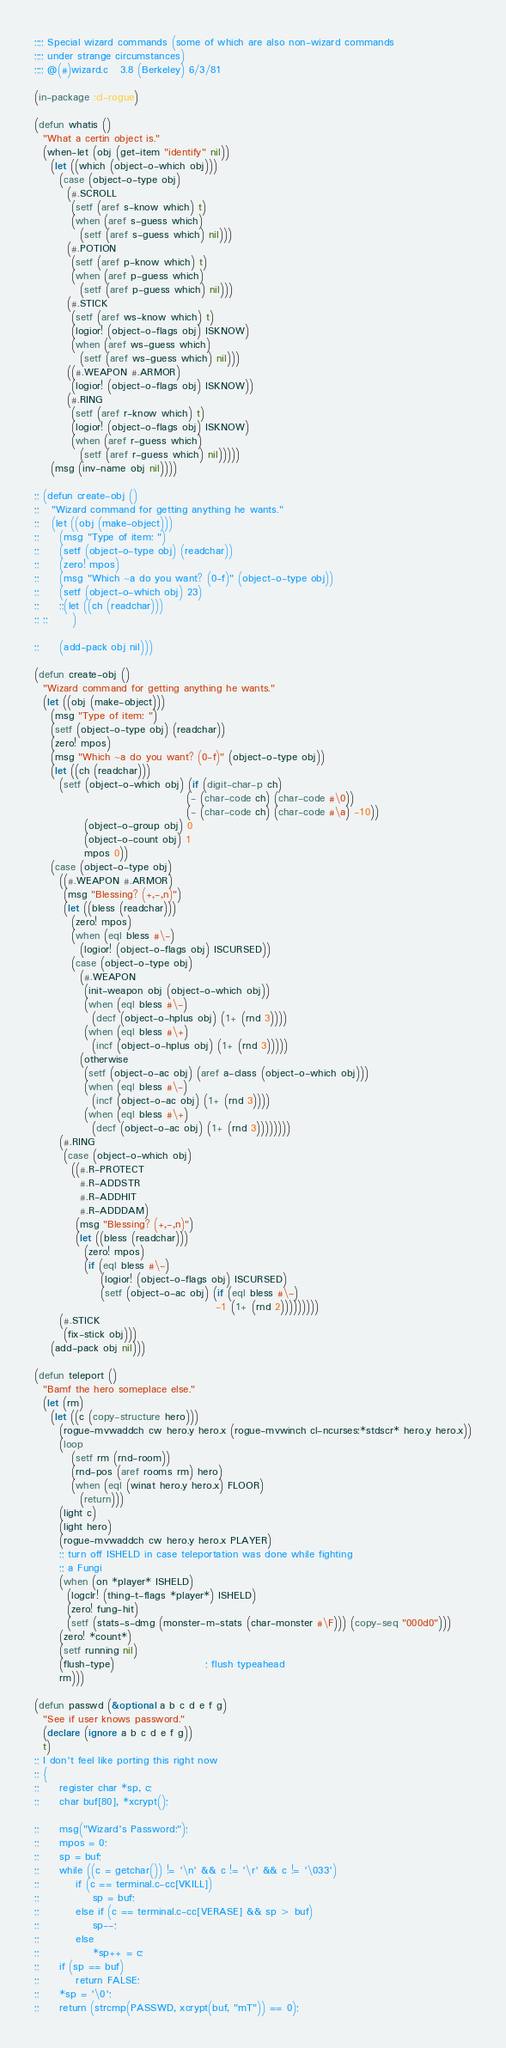<code> <loc_0><loc_0><loc_500><loc_500><_Lisp_>;;;; Special wizard commands (some of which are also non-wizard commands
;;;; under strange circumstances)
;;;; @(#)wizard.c	3.8 (Berkeley) 6/3/81

(in-package :cl-rogue)

(defun whatis ()
  "What a certin object is."
  (when-let (obj (get-item "identify" nil))
    (let ((which (object-o-which obj)))
      (case (object-o-type obj)
        (#.SCROLL
         (setf (aref s-know which) t)
         (when (aref s-guess which)
           (setf (aref s-guess which) nil)))
        (#.POTION
         (setf (aref p-know which) t)
         (when (aref p-guess which)
           (setf (aref p-guess which) nil)))
        (#.STICK
         (setf (aref ws-know which) t)
         (logior! (object-o-flags obj) ISKNOW)
         (when (aref ws-guess which)
           (setf (aref ws-guess which) nil)))
        ((#.WEAPON #.ARMOR)
         (logior! (object-o-flags obj) ISKNOW))
        (#.RING
         (setf (aref r-know which) t)
         (logior! (object-o-flags obj) ISKNOW)
         (when (aref r-guess which)
           (setf (aref r-guess which) nil)))))
    (msg (inv-name obj nil))))

;; (defun create-obj ()
;;   "Wizard command for getting anything he wants."
;;   (let ((obj (make-object)))
;;     (msg "Type of item: ")
;;     (setf (object-o-type obj) (readchar))
;;     (zero! mpos)
;;     (msg "Which ~a do you want? (0-f)" (object-o-type obj))
;;     (setf (object-o-which obj) 23)
;;     ;;(let ((ch (readchar)))
;; ;;      )
    
;;     (add-pack obj nil)))

(defun create-obj ()
  "Wizard command for getting anything he wants."
  (let ((obj (make-object)))
    (msg "Type of item: ")
    (setf (object-o-type obj) (readchar))
    (zero! mpos)
    (msg "Which ~a do you want? (0-f)" (object-o-type obj))
    (let ((ch (readchar)))
      (setf (object-o-which obj) (if (digit-char-p ch)
                                     (- (char-code ch) (char-code #\0))
                                     (- (char-code ch) (char-code #\a) -10))
            (object-o-group obj) 0
            (object-o-count obj) 1
            mpos 0))
    (case (object-o-type obj)
      ((#.WEAPON #.ARMOR)
       (msg "Blessing? (+,-,n)")
       (let ((bless (readchar)))
         (zero! mpos)
         (when (eql bless #\-)
           (logior! (object-o-flags obj) ISCURSED))
         (case (object-o-type obj)
           (#.WEAPON
            (init-weapon obj (object-o-which obj))
            (when (eql bless #\-)
              (decf (object-o-hplus obj) (1+ (rnd 3))))
            (when (eql bless #\+)
              (incf (object-o-hplus obj) (1+ (rnd 3)))))
           (otherwise
            (setf (object-o-ac obj) (aref a-class (object-o-which obj)))
            (when (eql bless #\-)
              (incf (object-o-ac obj) (1+ (rnd 3))))
            (when (eql bless #\+)
              (decf (object-o-ac obj) (1+ (rnd 3))))))))
      (#.RING
       (case (object-o-which obj)
         ((#.R-PROTECT
           #.R-ADDSTR
           #.R-ADDHIT
           #.R-ADDDAM)
          (msg "Blessing? (+,-,n)")
          (let ((bless (readchar)))
            (zero! mpos)
            (if (eql bless #\-)
                (logior! (object-o-flags obj) ISCURSED)
                (setf (object-o-ac obj) (if (eql bless #\-)
                                            -1 (1+ (rnd 2)))))))))
      (#.STICK
       (fix-stick obj)))
    (add-pack obj nil)))

(defun teleport ()
  "Bamf the hero someplace else."
  (let (rm)
    (let ((c (copy-structure hero)))
      (rogue-mvwaddch cw hero.y hero.x (rogue-mvwinch cl-ncurses:*stdscr* hero.y hero.x))
      (loop
         (setf rm (rnd-room))
         (rnd-pos (aref rooms rm) hero)
         (when (eql (winat hero.y hero.x) FLOOR) 
           (return)))
      (light c)
      (light hero)
      (rogue-mvwaddch cw hero.y hero.x PLAYER)
      ;; turn off ISHELD in case teleportation was done while fighting
      ;; a Fungi
      (when (on *player* ISHELD)
        (logclr! (thing-t-flags *player*) ISHELD)
        (zero! fung-hit)
        (setf (stats-s-dmg (monster-m-stats (char-monster #\F))) (copy-seq "000d0")))
      (zero! *count*)
      (setf running nil)
      (flush-type)                      ; flush typeahead
      rm)))

(defun passwd (&optional a b c d e f g)
  "See if user knows password."
  (declare (ignore a b c d e f g))
  t)
;; I don't feel like porting this right now
;; {
;;     register char *sp, c;
;;     char buf[80], *xcrypt();

;;     msg("Wizard's Password:");
;;     mpos = 0;
;;     sp = buf;
;;     while ((c = getchar()) != '\n' && c != '\r' && c != '\033')
;;         if (c == terminal.c-cc[VKILL])
;;             sp = buf;
;;         else if (c == terminal.c-cc[VERASE] && sp > buf)
;;             sp--;
;;         else
;;             *sp++ = c;
;;     if (sp == buf)
;;         return FALSE;
;;     *sp = '\0';
;;     return (strcmp(PASSWD, xcrypt(buf, "mT")) == 0);

</code> 